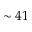<formula> <loc_0><loc_0><loc_500><loc_500>\sim 4 1</formula> 